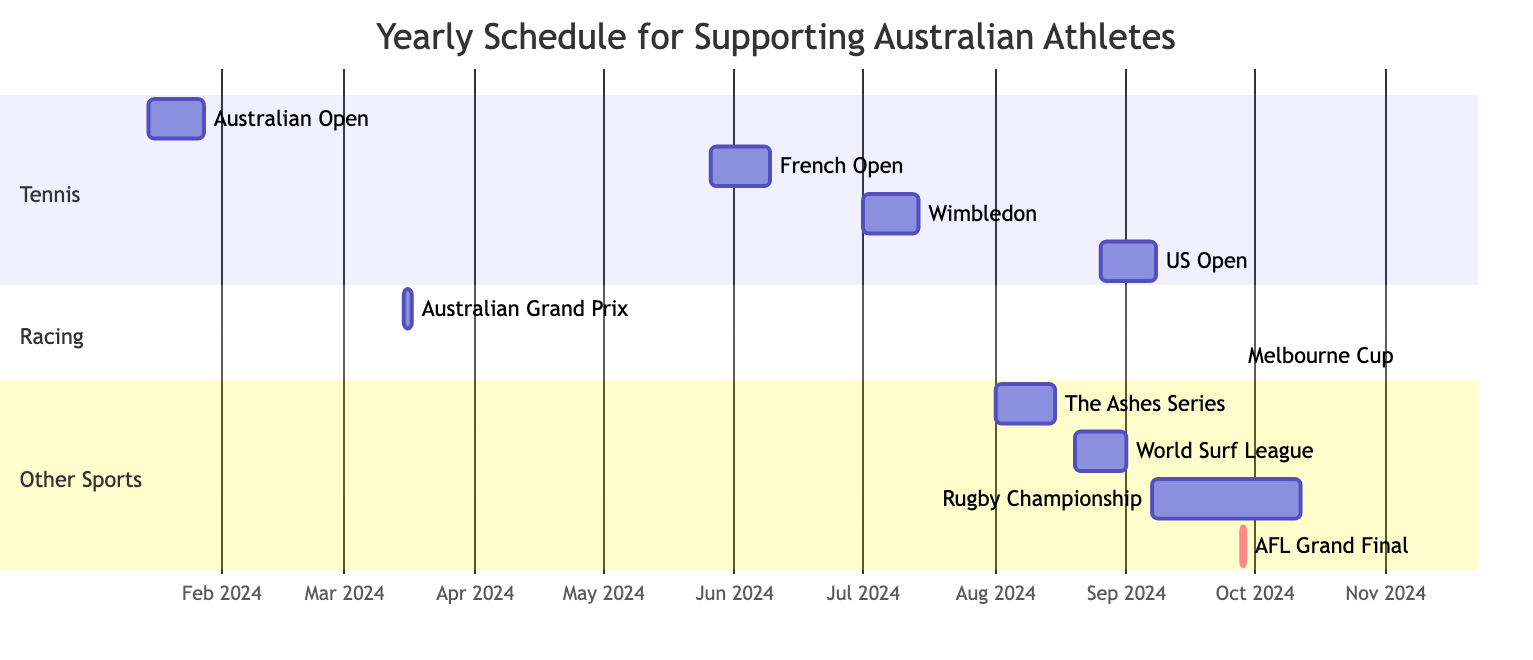What is the duration of the Australian Open? The Australian Open starts on January 15, 2024, and ends on January 28, 2024. To find the duration, count the days from the start date to the end date, inclusive. This gives us a total of 14 days.
Answer: 14 days Where will the Wimbledon tournament take place? The diagram shows that Wimbledon is scheduled from July 1, 2024, to July 14, 2024, and its location is indicated next to the event. According to the details, Wimbledon will be held in London, United Kingdom.
Answer: London, United Kingdom What events occur during August 2024? According to the diagram, the events listed for August 2024 include The Ashes Series, which occurs from August 1 to August 15, and the World Surf League Championship Tour, which runs from August 20 to September 1. Therefore, we will list both events in August.
Answer: The Ashes Series, World Surf League How many Grand Slam tennis tournaments are in the schedule? By analyzing the "Tennis" section in the Gantt chart, we see four Grand Slam tournaments: Australian Open, French Open, Wimbledon, and US Open. Since we count all listed tournaments, the total is four.
Answer: 4 Which event is the only one that occurs on a single day? Looking at the diagram, the Australian Football League Grand Final is noted to occur on just one day, September 28, 2024. The "1d" designation indicates it takes place within that single day only.
Answer: Australian Football League Grand Final When is the Rugby Championship scheduled to start? The Rugby Championship is detailed in the Gantt chart as having a start date of September 7, 2024. This is stated alongside its overall duration listed in the "Other Sports" section.
Answer: September 7, 2024 Which sporting event occurs last in the schedule? By reviewing the end dates in the Gantt chart, we find that the last scheduled event is the Melbourne Cup on November 5, 2024. This is after considering the end dates of all other events listed.
Answer: Melbourne Cup What is the timeframe for the US Open? The US Open is listed in the diagram with a start date of August 26, 2024, and an end date of September 8, 2024. We can calculate the timeframe by looking at these two dates.
Answer: August 26 to September 8, 2024 Which sport has the most events scheduled in this year? By examining the diagram, we can categorize events into sports. Tennis has four events (Australian Open, French Open, Wimbledon, and US Open), whereas racing only has two and other sports have three events. Thus, tennis has the most events.
Answer: Tennis 